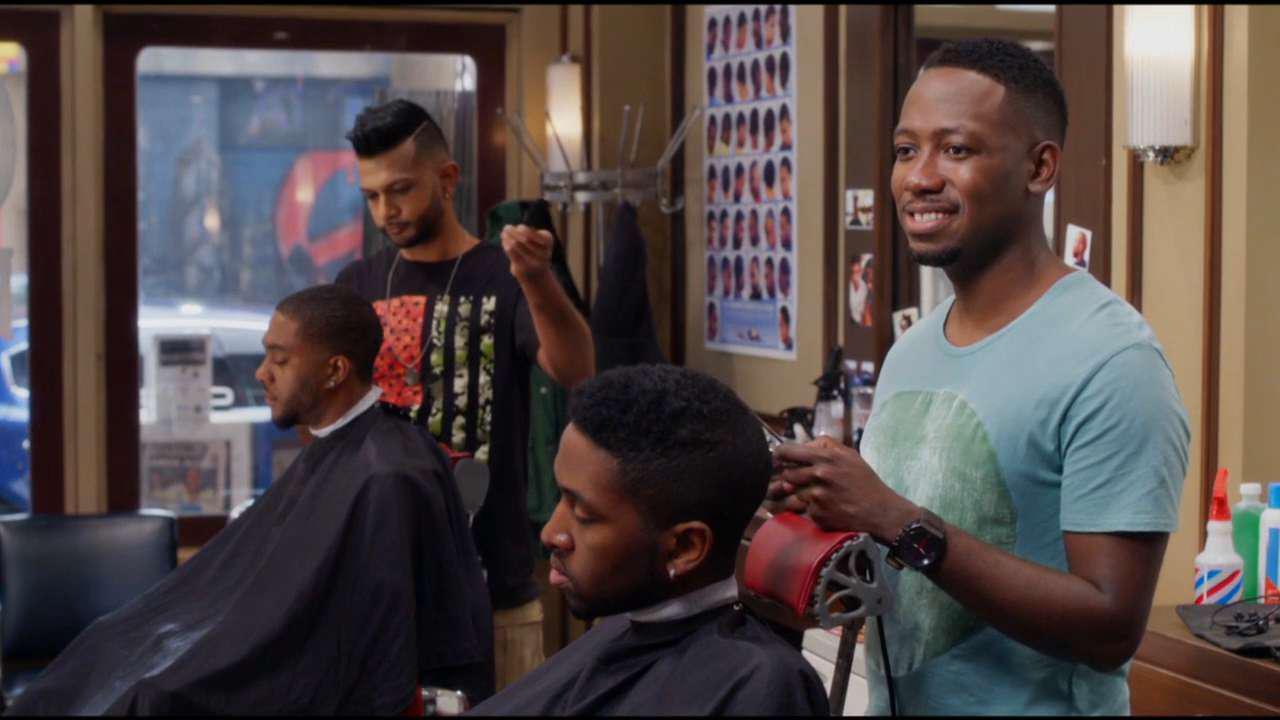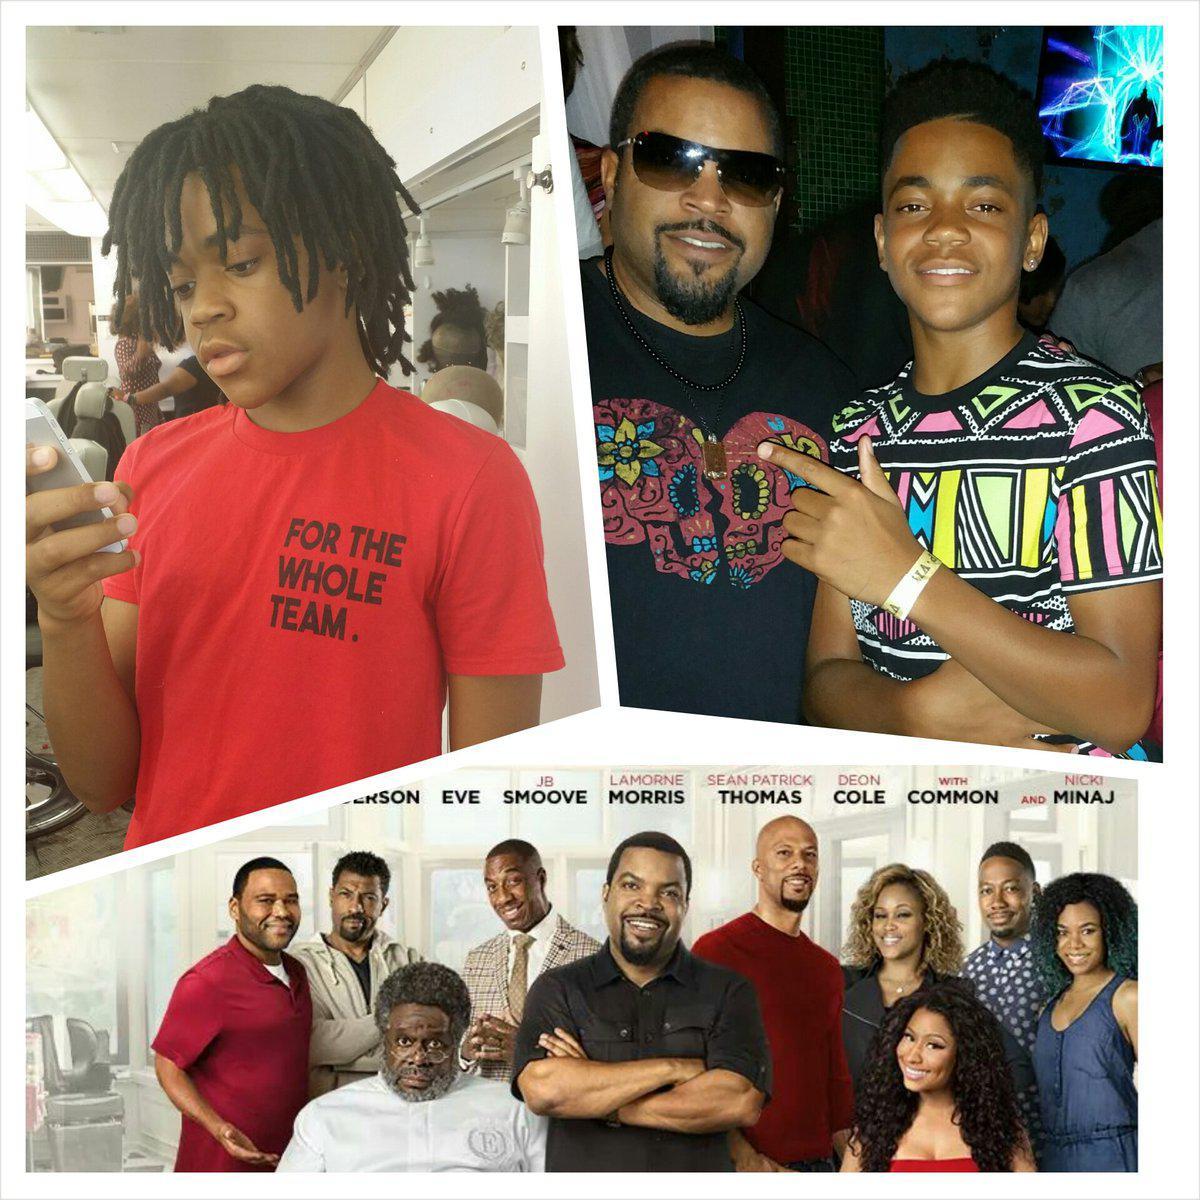The first image is the image on the left, the second image is the image on the right. Assess this claim about the two images: "Caucasian males are getting their hair cut". Correct or not? Answer yes or no. No. The first image is the image on the left, the second image is the image on the right. Evaluate the accuracy of this statement regarding the images: "At least one image shows a male barber standing to work on a customer's hair.". Is it true? Answer yes or no. Yes. 